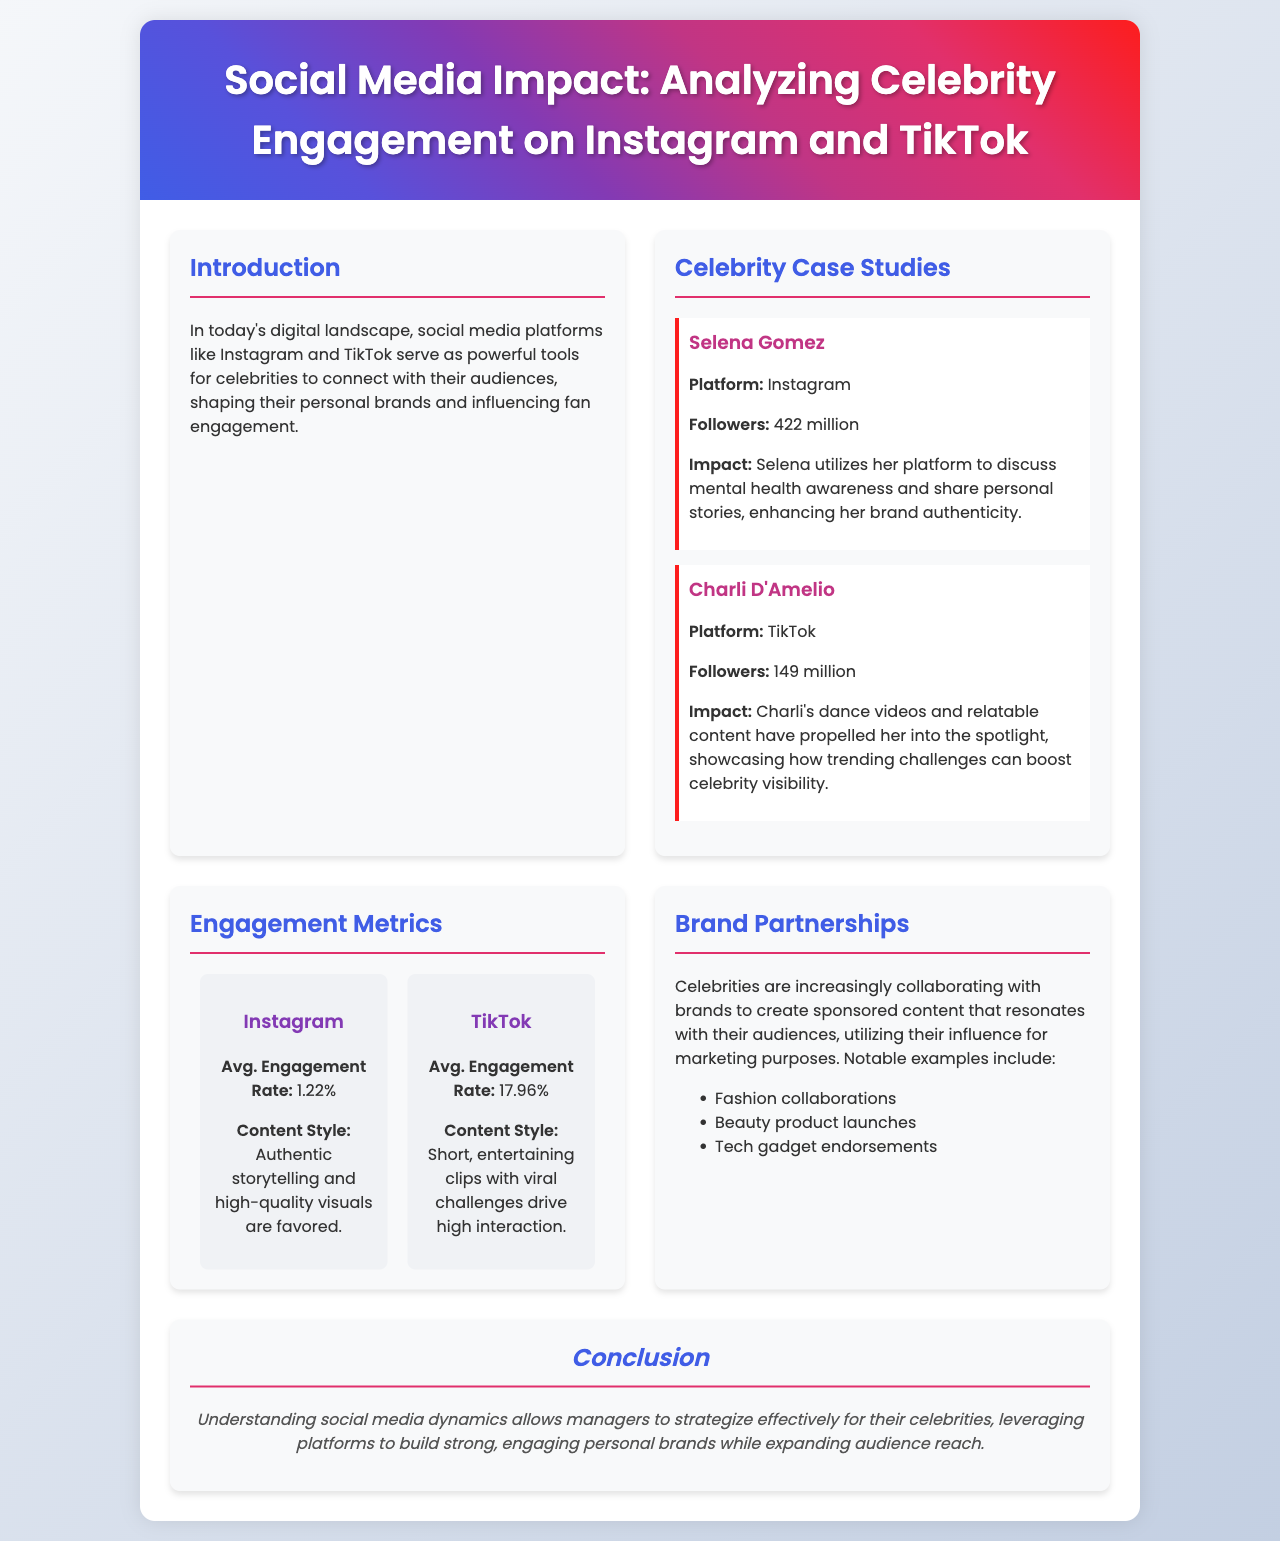What is the main focus of the brochure? The brochure focuses on the impact of social media on celebrity engagement on platforms like Instagram and TikTok.
Answer: Social media impact How many followers does Selena Gomez have? The document states that Selena Gomez has 422 million followers on Instagram.
Answer: 422 million What is Charli D'Amelio's primary social media platform? The document identifies TikTok as Charli D'Amelio's primary platform.
Answer: TikTok What is the average engagement rate on TikTok? The average engagement rate for TikTok mentioned in the document is 17.96%.
Answer: 17.96% What type of content drives high interaction on TikTok? The document says that short, entertaining clips with viral challenges drive high interaction on TikTok.
Answer: Short, entertaining clips Which platform has a higher average engagement rate? Comparing the engagement rates listed in the document, TikTok has a higher average engagement rate than Instagram.
Answer: TikTok What does the introduction highlight about social media platforms? The introduction emphasizes that social media allows celebrities to connect with audiences and shape personal brands.
Answer: Connect with audiences What are common types of brand partnerships mentioned? The document lists fashion collaborations, beauty product launches, and tech gadget endorsements as examples.
Answer: Fashion collaborations, beauty product launches, tech gadget endorsements What is emphasized in the conclusion of the brochure? The conclusion emphasizes the importance of understanding social media dynamics for managing celebrity brands effectively.
Answer: Understanding social media dynamics 